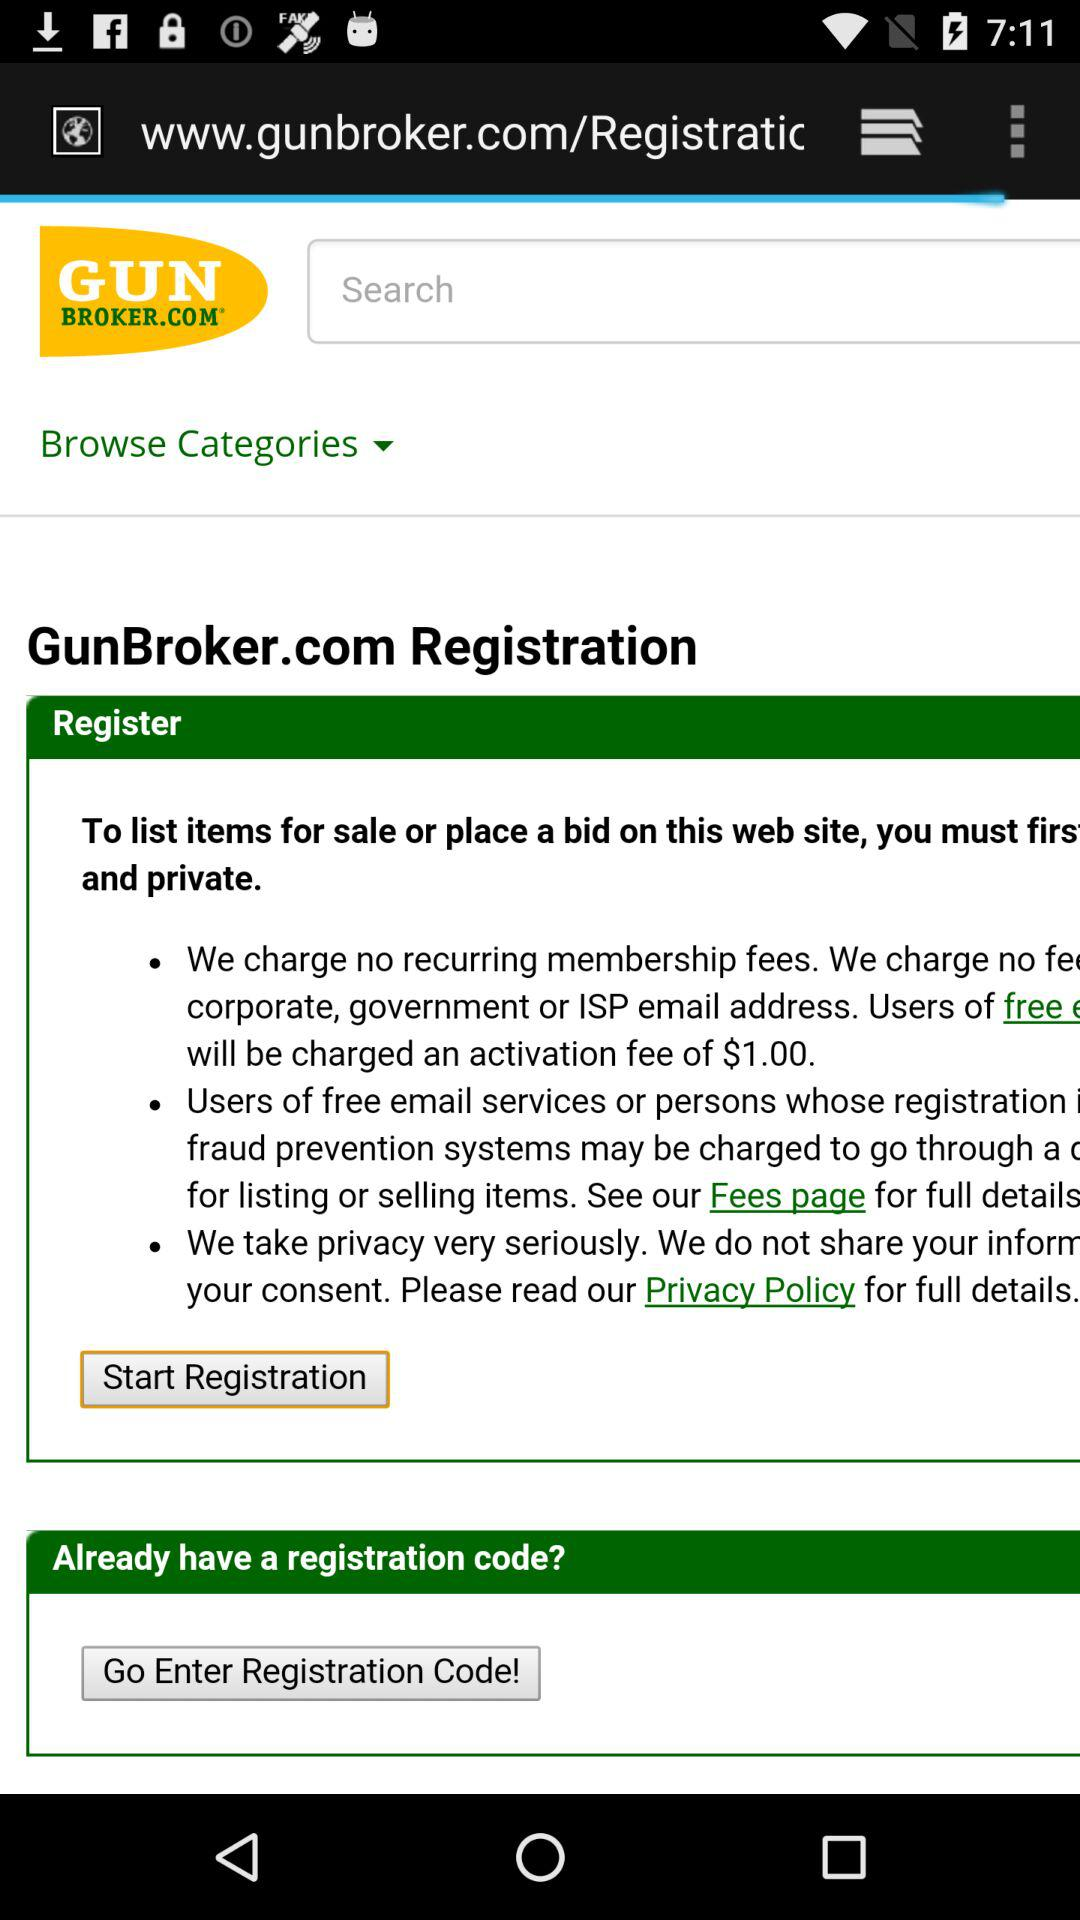What is the application name? The application name is "GunBroker.com". 